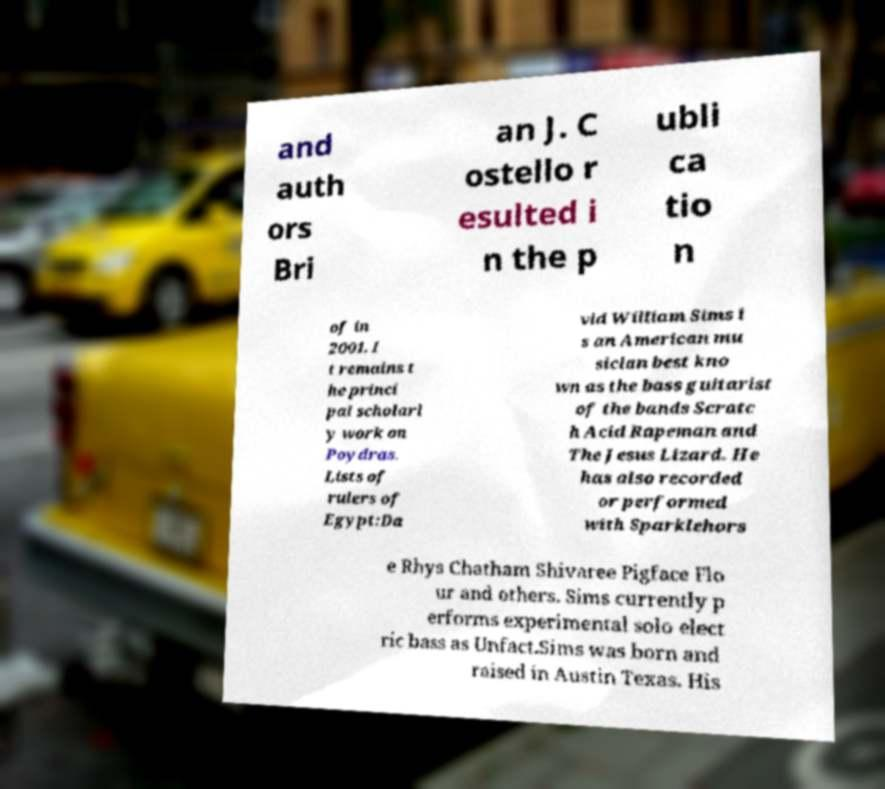Could you extract and type out the text from this image? and auth ors Bri an J. C ostello r esulted i n the p ubli ca tio n of in 2001. I t remains t he princi pal scholarl y work on Poydras. Lists of rulers of Egypt:Da vid William Sims i s an American mu sician best kno wn as the bass guitarist of the bands Scratc h Acid Rapeman and The Jesus Lizard. He has also recorded or performed with Sparklehors e Rhys Chatham Shivaree Pigface Flo ur and others. Sims currently p erforms experimental solo elect ric bass as Unfact.Sims was born and raised in Austin Texas. His 